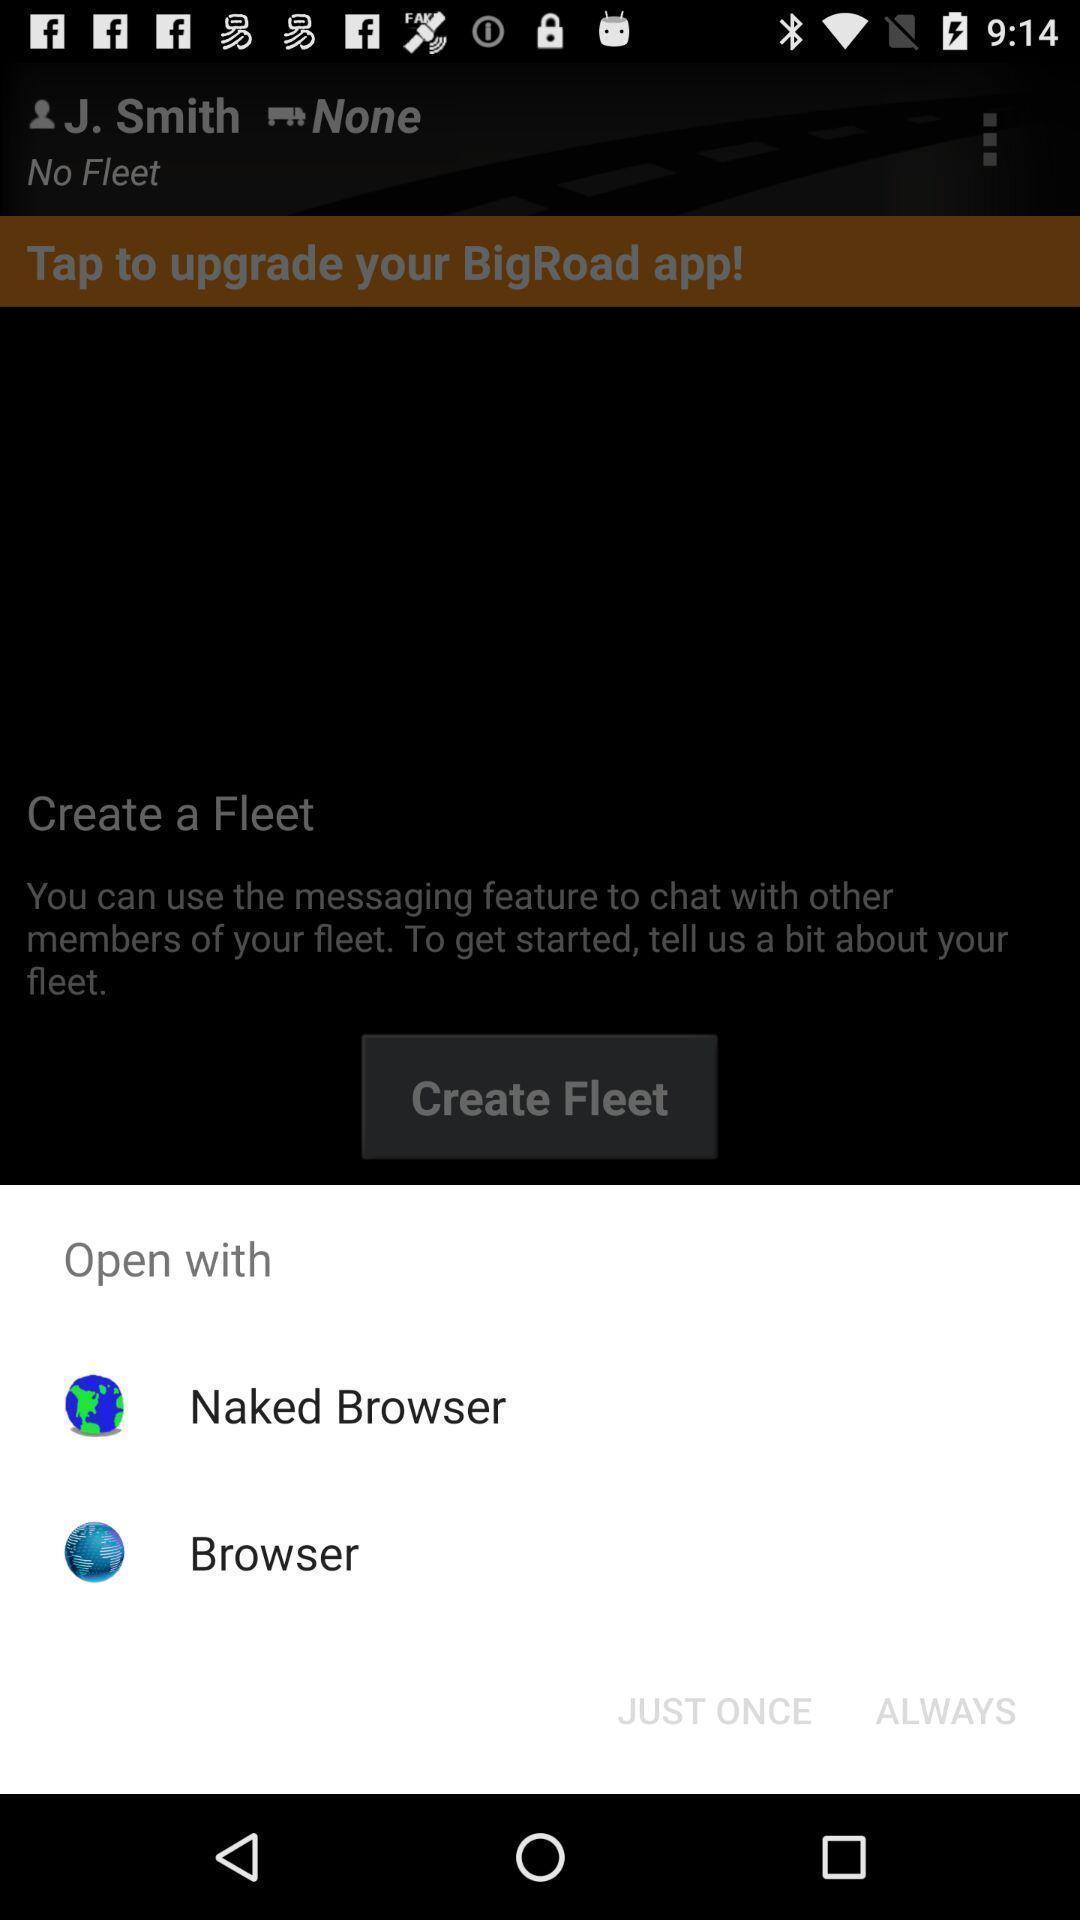Please provide a description for this image. Pop-up showing various options to open with. 